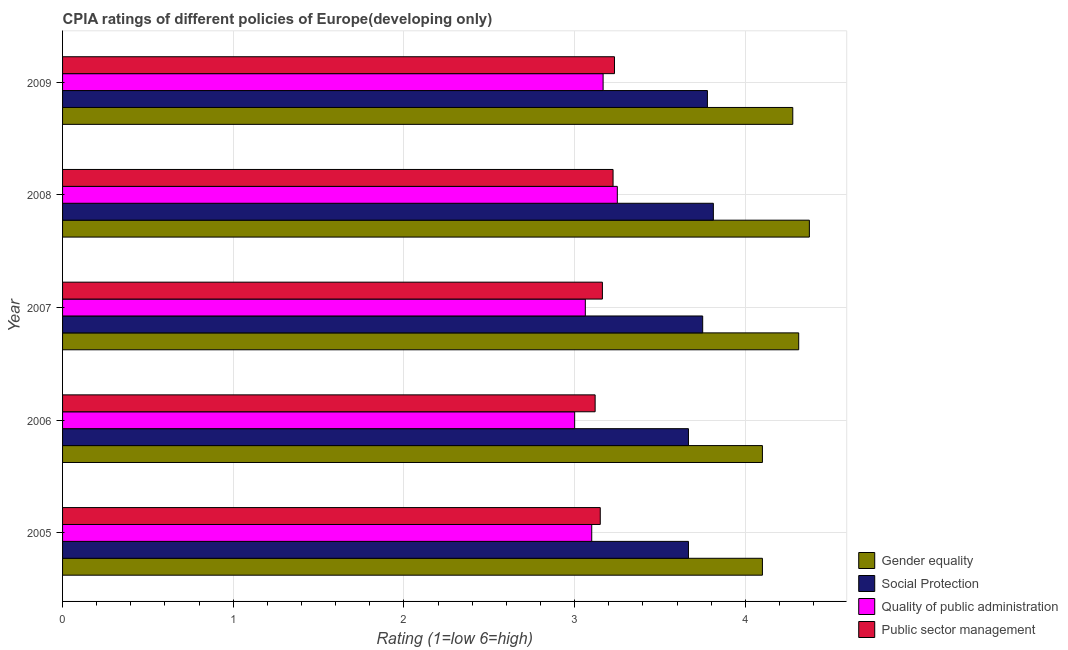How many groups of bars are there?
Your answer should be very brief. 5. Are the number of bars on each tick of the Y-axis equal?
Ensure brevity in your answer.  Yes. How many bars are there on the 2nd tick from the top?
Provide a succinct answer. 4. What is the label of the 4th group of bars from the top?
Offer a terse response. 2006. In how many cases, is the number of bars for a given year not equal to the number of legend labels?
Keep it short and to the point. 0. What is the cpia rating of social protection in 2005?
Your response must be concise. 3.67. Across all years, what is the maximum cpia rating of public sector management?
Offer a very short reply. 3.23. In which year was the cpia rating of gender equality maximum?
Provide a short and direct response. 2008. In which year was the cpia rating of quality of public administration minimum?
Keep it short and to the point. 2006. What is the total cpia rating of public sector management in the graph?
Make the answer very short. 15.89. What is the difference between the cpia rating of public sector management in 2006 and that in 2008?
Provide a succinct answer. -0.1. What is the difference between the cpia rating of social protection in 2006 and the cpia rating of quality of public administration in 2008?
Keep it short and to the point. 0.42. What is the average cpia rating of public sector management per year?
Give a very brief answer. 3.18. In the year 2009, what is the difference between the cpia rating of gender equality and cpia rating of public sector management?
Ensure brevity in your answer.  1.04. In how many years, is the cpia rating of public sector management greater than 0.4 ?
Provide a short and direct response. 5. What is the ratio of the cpia rating of quality of public administration in 2007 to that in 2008?
Provide a succinct answer. 0.94. Is the difference between the cpia rating of social protection in 2005 and 2008 greater than the difference between the cpia rating of gender equality in 2005 and 2008?
Make the answer very short. Yes. What is the difference between the highest and the second highest cpia rating of social protection?
Your answer should be very brief. 0.04. What is the difference between the highest and the lowest cpia rating of gender equality?
Offer a terse response. 0.28. In how many years, is the cpia rating of public sector management greater than the average cpia rating of public sector management taken over all years?
Offer a very short reply. 2. Is the sum of the cpia rating of quality of public administration in 2005 and 2009 greater than the maximum cpia rating of public sector management across all years?
Your answer should be compact. Yes. What does the 4th bar from the top in 2009 represents?
Give a very brief answer. Gender equality. What does the 1st bar from the bottom in 2005 represents?
Your response must be concise. Gender equality. Is it the case that in every year, the sum of the cpia rating of gender equality and cpia rating of social protection is greater than the cpia rating of quality of public administration?
Make the answer very short. Yes. How many bars are there?
Offer a terse response. 20. Are all the bars in the graph horizontal?
Offer a very short reply. Yes. How many years are there in the graph?
Your response must be concise. 5. Are the values on the major ticks of X-axis written in scientific E-notation?
Make the answer very short. No. How are the legend labels stacked?
Your answer should be very brief. Vertical. What is the title of the graph?
Make the answer very short. CPIA ratings of different policies of Europe(developing only). Does "Coal" appear as one of the legend labels in the graph?
Keep it short and to the point. No. What is the label or title of the X-axis?
Provide a succinct answer. Rating (1=low 6=high). What is the Rating (1=low 6=high) of Gender equality in 2005?
Offer a very short reply. 4.1. What is the Rating (1=low 6=high) in Social Protection in 2005?
Your answer should be very brief. 3.67. What is the Rating (1=low 6=high) of Public sector management in 2005?
Keep it short and to the point. 3.15. What is the Rating (1=low 6=high) of Social Protection in 2006?
Provide a succinct answer. 3.67. What is the Rating (1=low 6=high) of Public sector management in 2006?
Provide a short and direct response. 3.12. What is the Rating (1=low 6=high) of Gender equality in 2007?
Offer a terse response. 4.31. What is the Rating (1=low 6=high) in Social Protection in 2007?
Make the answer very short. 3.75. What is the Rating (1=low 6=high) of Quality of public administration in 2007?
Your answer should be very brief. 3.06. What is the Rating (1=low 6=high) of Public sector management in 2007?
Offer a very short reply. 3.16. What is the Rating (1=low 6=high) of Gender equality in 2008?
Offer a very short reply. 4.38. What is the Rating (1=low 6=high) in Social Protection in 2008?
Provide a short and direct response. 3.81. What is the Rating (1=low 6=high) in Public sector management in 2008?
Give a very brief answer. 3.23. What is the Rating (1=low 6=high) of Gender equality in 2009?
Provide a short and direct response. 4.28. What is the Rating (1=low 6=high) of Social Protection in 2009?
Offer a terse response. 3.78. What is the Rating (1=low 6=high) of Quality of public administration in 2009?
Ensure brevity in your answer.  3.17. What is the Rating (1=low 6=high) in Public sector management in 2009?
Offer a terse response. 3.23. Across all years, what is the maximum Rating (1=low 6=high) in Gender equality?
Give a very brief answer. 4.38. Across all years, what is the maximum Rating (1=low 6=high) in Social Protection?
Make the answer very short. 3.81. Across all years, what is the maximum Rating (1=low 6=high) of Quality of public administration?
Your answer should be compact. 3.25. Across all years, what is the maximum Rating (1=low 6=high) of Public sector management?
Your answer should be very brief. 3.23. Across all years, what is the minimum Rating (1=low 6=high) in Gender equality?
Offer a very short reply. 4.1. Across all years, what is the minimum Rating (1=low 6=high) of Social Protection?
Ensure brevity in your answer.  3.67. Across all years, what is the minimum Rating (1=low 6=high) of Public sector management?
Provide a short and direct response. 3.12. What is the total Rating (1=low 6=high) in Gender equality in the graph?
Make the answer very short. 21.17. What is the total Rating (1=low 6=high) in Social Protection in the graph?
Your answer should be compact. 18.67. What is the total Rating (1=low 6=high) in Quality of public administration in the graph?
Ensure brevity in your answer.  15.58. What is the total Rating (1=low 6=high) of Public sector management in the graph?
Ensure brevity in your answer.  15.89. What is the difference between the Rating (1=low 6=high) of Social Protection in 2005 and that in 2006?
Ensure brevity in your answer.  0. What is the difference between the Rating (1=low 6=high) in Quality of public administration in 2005 and that in 2006?
Your answer should be very brief. 0.1. What is the difference between the Rating (1=low 6=high) of Public sector management in 2005 and that in 2006?
Your response must be concise. 0.03. What is the difference between the Rating (1=low 6=high) in Gender equality in 2005 and that in 2007?
Make the answer very short. -0.21. What is the difference between the Rating (1=low 6=high) in Social Protection in 2005 and that in 2007?
Offer a very short reply. -0.08. What is the difference between the Rating (1=low 6=high) in Quality of public administration in 2005 and that in 2007?
Your response must be concise. 0.04. What is the difference between the Rating (1=low 6=high) in Public sector management in 2005 and that in 2007?
Your answer should be compact. -0.01. What is the difference between the Rating (1=low 6=high) in Gender equality in 2005 and that in 2008?
Offer a terse response. -0.28. What is the difference between the Rating (1=low 6=high) of Social Protection in 2005 and that in 2008?
Provide a succinct answer. -0.15. What is the difference between the Rating (1=low 6=high) in Public sector management in 2005 and that in 2008?
Offer a very short reply. -0.07. What is the difference between the Rating (1=low 6=high) of Gender equality in 2005 and that in 2009?
Offer a terse response. -0.18. What is the difference between the Rating (1=low 6=high) of Social Protection in 2005 and that in 2009?
Offer a very short reply. -0.11. What is the difference between the Rating (1=low 6=high) of Quality of public administration in 2005 and that in 2009?
Ensure brevity in your answer.  -0.07. What is the difference between the Rating (1=low 6=high) in Public sector management in 2005 and that in 2009?
Your response must be concise. -0.08. What is the difference between the Rating (1=low 6=high) in Gender equality in 2006 and that in 2007?
Your response must be concise. -0.21. What is the difference between the Rating (1=low 6=high) of Social Protection in 2006 and that in 2007?
Provide a short and direct response. -0.08. What is the difference between the Rating (1=low 6=high) of Quality of public administration in 2006 and that in 2007?
Make the answer very short. -0.06. What is the difference between the Rating (1=low 6=high) in Public sector management in 2006 and that in 2007?
Provide a succinct answer. -0.04. What is the difference between the Rating (1=low 6=high) of Gender equality in 2006 and that in 2008?
Your response must be concise. -0.28. What is the difference between the Rating (1=low 6=high) of Social Protection in 2006 and that in 2008?
Make the answer very short. -0.15. What is the difference between the Rating (1=low 6=high) of Quality of public administration in 2006 and that in 2008?
Your response must be concise. -0.25. What is the difference between the Rating (1=low 6=high) of Public sector management in 2006 and that in 2008?
Ensure brevity in your answer.  -0.1. What is the difference between the Rating (1=low 6=high) of Gender equality in 2006 and that in 2009?
Provide a short and direct response. -0.18. What is the difference between the Rating (1=low 6=high) of Social Protection in 2006 and that in 2009?
Provide a succinct answer. -0.11. What is the difference between the Rating (1=low 6=high) in Quality of public administration in 2006 and that in 2009?
Keep it short and to the point. -0.17. What is the difference between the Rating (1=low 6=high) of Public sector management in 2006 and that in 2009?
Ensure brevity in your answer.  -0.11. What is the difference between the Rating (1=low 6=high) of Gender equality in 2007 and that in 2008?
Offer a very short reply. -0.06. What is the difference between the Rating (1=low 6=high) in Social Protection in 2007 and that in 2008?
Offer a very short reply. -0.06. What is the difference between the Rating (1=low 6=high) of Quality of public administration in 2007 and that in 2008?
Offer a very short reply. -0.19. What is the difference between the Rating (1=low 6=high) of Public sector management in 2007 and that in 2008?
Keep it short and to the point. -0.06. What is the difference between the Rating (1=low 6=high) of Gender equality in 2007 and that in 2009?
Your answer should be very brief. 0.03. What is the difference between the Rating (1=low 6=high) in Social Protection in 2007 and that in 2009?
Ensure brevity in your answer.  -0.03. What is the difference between the Rating (1=low 6=high) in Quality of public administration in 2007 and that in 2009?
Provide a succinct answer. -0.1. What is the difference between the Rating (1=low 6=high) in Public sector management in 2007 and that in 2009?
Offer a terse response. -0.07. What is the difference between the Rating (1=low 6=high) in Gender equality in 2008 and that in 2009?
Ensure brevity in your answer.  0.1. What is the difference between the Rating (1=low 6=high) in Social Protection in 2008 and that in 2009?
Make the answer very short. 0.03. What is the difference between the Rating (1=low 6=high) of Quality of public administration in 2008 and that in 2009?
Your answer should be very brief. 0.08. What is the difference between the Rating (1=low 6=high) in Public sector management in 2008 and that in 2009?
Your response must be concise. -0.01. What is the difference between the Rating (1=low 6=high) of Gender equality in 2005 and the Rating (1=low 6=high) of Social Protection in 2006?
Ensure brevity in your answer.  0.43. What is the difference between the Rating (1=low 6=high) of Gender equality in 2005 and the Rating (1=low 6=high) of Quality of public administration in 2006?
Offer a terse response. 1.1. What is the difference between the Rating (1=low 6=high) of Social Protection in 2005 and the Rating (1=low 6=high) of Public sector management in 2006?
Your answer should be very brief. 0.55. What is the difference between the Rating (1=low 6=high) of Quality of public administration in 2005 and the Rating (1=low 6=high) of Public sector management in 2006?
Make the answer very short. -0.02. What is the difference between the Rating (1=low 6=high) of Gender equality in 2005 and the Rating (1=low 6=high) of Social Protection in 2007?
Keep it short and to the point. 0.35. What is the difference between the Rating (1=low 6=high) in Gender equality in 2005 and the Rating (1=low 6=high) in Quality of public administration in 2007?
Provide a short and direct response. 1.04. What is the difference between the Rating (1=low 6=high) of Gender equality in 2005 and the Rating (1=low 6=high) of Public sector management in 2007?
Make the answer very short. 0.94. What is the difference between the Rating (1=low 6=high) in Social Protection in 2005 and the Rating (1=low 6=high) in Quality of public administration in 2007?
Give a very brief answer. 0.6. What is the difference between the Rating (1=low 6=high) of Social Protection in 2005 and the Rating (1=low 6=high) of Public sector management in 2007?
Keep it short and to the point. 0.5. What is the difference between the Rating (1=low 6=high) in Quality of public administration in 2005 and the Rating (1=low 6=high) in Public sector management in 2007?
Provide a short and direct response. -0.06. What is the difference between the Rating (1=low 6=high) in Gender equality in 2005 and the Rating (1=low 6=high) in Social Protection in 2008?
Your answer should be very brief. 0.29. What is the difference between the Rating (1=low 6=high) of Gender equality in 2005 and the Rating (1=low 6=high) of Quality of public administration in 2008?
Make the answer very short. 0.85. What is the difference between the Rating (1=low 6=high) of Gender equality in 2005 and the Rating (1=low 6=high) of Public sector management in 2008?
Your answer should be compact. 0.88. What is the difference between the Rating (1=low 6=high) in Social Protection in 2005 and the Rating (1=low 6=high) in Quality of public administration in 2008?
Your answer should be compact. 0.42. What is the difference between the Rating (1=low 6=high) in Social Protection in 2005 and the Rating (1=low 6=high) in Public sector management in 2008?
Your answer should be very brief. 0.44. What is the difference between the Rating (1=low 6=high) of Quality of public administration in 2005 and the Rating (1=low 6=high) of Public sector management in 2008?
Your answer should be very brief. -0.12. What is the difference between the Rating (1=low 6=high) in Gender equality in 2005 and the Rating (1=low 6=high) in Social Protection in 2009?
Your response must be concise. 0.32. What is the difference between the Rating (1=low 6=high) of Gender equality in 2005 and the Rating (1=low 6=high) of Public sector management in 2009?
Your answer should be compact. 0.87. What is the difference between the Rating (1=low 6=high) in Social Protection in 2005 and the Rating (1=low 6=high) in Quality of public administration in 2009?
Offer a very short reply. 0.5. What is the difference between the Rating (1=low 6=high) in Social Protection in 2005 and the Rating (1=low 6=high) in Public sector management in 2009?
Your response must be concise. 0.43. What is the difference between the Rating (1=low 6=high) in Quality of public administration in 2005 and the Rating (1=low 6=high) in Public sector management in 2009?
Provide a short and direct response. -0.13. What is the difference between the Rating (1=low 6=high) of Gender equality in 2006 and the Rating (1=low 6=high) of Social Protection in 2007?
Make the answer very short. 0.35. What is the difference between the Rating (1=low 6=high) in Gender equality in 2006 and the Rating (1=low 6=high) in Quality of public administration in 2007?
Offer a very short reply. 1.04. What is the difference between the Rating (1=low 6=high) in Social Protection in 2006 and the Rating (1=low 6=high) in Quality of public administration in 2007?
Provide a succinct answer. 0.6. What is the difference between the Rating (1=low 6=high) of Social Protection in 2006 and the Rating (1=low 6=high) of Public sector management in 2007?
Keep it short and to the point. 0.5. What is the difference between the Rating (1=low 6=high) of Quality of public administration in 2006 and the Rating (1=low 6=high) of Public sector management in 2007?
Offer a very short reply. -0.16. What is the difference between the Rating (1=low 6=high) in Gender equality in 2006 and the Rating (1=low 6=high) in Social Protection in 2008?
Your response must be concise. 0.29. What is the difference between the Rating (1=low 6=high) in Social Protection in 2006 and the Rating (1=low 6=high) in Quality of public administration in 2008?
Your response must be concise. 0.42. What is the difference between the Rating (1=low 6=high) in Social Protection in 2006 and the Rating (1=low 6=high) in Public sector management in 2008?
Offer a terse response. 0.44. What is the difference between the Rating (1=low 6=high) of Quality of public administration in 2006 and the Rating (1=low 6=high) of Public sector management in 2008?
Give a very brief answer. -0.23. What is the difference between the Rating (1=low 6=high) of Gender equality in 2006 and the Rating (1=low 6=high) of Social Protection in 2009?
Your answer should be very brief. 0.32. What is the difference between the Rating (1=low 6=high) in Gender equality in 2006 and the Rating (1=low 6=high) in Public sector management in 2009?
Your response must be concise. 0.87. What is the difference between the Rating (1=low 6=high) in Social Protection in 2006 and the Rating (1=low 6=high) in Public sector management in 2009?
Your response must be concise. 0.43. What is the difference between the Rating (1=low 6=high) of Quality of public administration in 2006 and the Rating (1=low 6=high) of Public sector management in 2009?
Your response must be concise. -0.23. What is the difference between the Rating (1=low 6=high) of Gender equality in 2007 and the Rating (1=low 6=high) of Quality of public administration in 2008?
Ensure brevity in your answer.  1.06. What is the difference between the Rating (1=low 6=high) of Gender equality in 2007 and the Rating (1=low 6=high) of Public sector management in 2008?
Offer a terse response. 1.09. What is the difference between the Rating (1=low 6=high) in Social Protection in 2007 and the Rating (1=low 6=high) in Quality of public administration in 2008?
Ensure brevity in your answer.  0.5. What is the difference between the Rating (1=low 6=high) of Social Protection in 2007 and the Rating (1=low 6=high) of Public sector management in 2008?
Ensure brevity in your answer.  0.53. What is the difference between the Rating (1=low 6=high) in Quality of public administration in 2007 and the Rating (1=low 6=high) in Public sector management in 2008?
Provide a succinct answer. -0.16. What is the difference between the Rating (1=low 6=high) of Gender equality in 2007 and the Rating (1=low 6=high) of Social Protection in 2009?
Keep it short and to the point. 0.53. What is the difference between the Rating (1=low 6=high) of Gender equality in 2007 and the Rating (1=low 6=high) of Quality of public administration in 2009?
Your response must be concise. 1.15. What is the difference between the Rating (1=low 6=high) in Gender equality in 2007 and the Rating (1=low 6=high) in Public sector management in 2009?
Offer a terse response. 1.08. What is the difference between the Rating (1=low 6=high) in Social Protection in 2007 and the Rating (1=low 6=high) in Quality of public administration in 2009?
Offer a very short reply. 0.58. What is the difference between the Rating (1=low 6=high) in Social Protection in 2007 and the Rating (1=low 6=high) in Public sector management in 2009?
Your answer should be compact. 0.52. What is the difference between the Rating (1=low 6=high) of Quality of public administration in 2007 and the Rating (1=low 6=high) of Public sector management in 2009?
Your response must be concise. -0.17. What is the difference between the Rating (1=low 6=high) of Gender equality in 2008 and the Rating (1=low 6=high) of Social Protection in 2009?
Give a very brief answer. 0.6. What is the difference between the Rating (1=low 6=high) in Gender equality in 2008 and the Rating (1=low 6=high) in Quality of public administration in 2009?
Your response must be concise. 1.21. What is the difference between the Rating (1=low 6=high) of Gender equality in 2008 and the Rating (1=low 6=high) of Public sector management in 2009?
Your response must be concise. 1.14. What is the difference between the Rating (1=low 6=high) in Social Protection in 2008 and the Rating (1=low 6=high) in Quality of public administration in 2009?
Provide a short and direct response. 0.65. What is the difference between the Rating (1=low 6=high) of Social Protection in 2008 and the Rating (1=low 6=high) of Public sector management in 2009?
Offer a terse response. 0.58. What is the difference between the Rating (1=low 6=high) in Quality of public administration in 2008 and the Rating (1=low 6=high) in Public sector management in 2009?
Your answer should be very brief. 0.02. What is the average Rating (1=low 6=high) in Gender equality per year?
Make the answer very short. 4.23. What is the average Rating (1=low 6=high) of Social Protection per year?
Provide a short and direct response. 3.73. What is the average Rating (1=low 6=high) of Quality of public administration per year?
Provide a succinct answer. 3.12. What is the average Rating (1=low 6=high) of Public sector management per year?
Your response must be concise. 3.18. In the year 2005, what is the difference between the Rating (1=low 6=high) of Gender equality and Rating (1=low 6=high) of Social Protection?
Give a very brief answer. 0.43. In the year 2005, what is the difference between the Rating (1=low 6=high) of Gender equality and Rating (1=low 6=high) of Quality of public administration?
Your response must be concise. 1. In the year 2005, what is the difference between the Rating (1=low 6=high) of Gender equality and Rating (1=low 6=high) of Public sector management?
Your answer should be very brief. 0.95. In the year 2005, what is the difference between the Rating (1=low 6=high) in Social Protection and Rating (1=low 6=high) in Quality of public administration?
Offer a terse response. 0.57. In the year 2005, what is the difference between the Rating (1=low 6=high) of Social Protection and Rating (1=low 6=high) of Public sector management?
Ensure brevity in your answer.  0.52. In the year 2006, what is the difference between the Rating (1=low 6=high) in Gender equality and Rating (1=low 6=high) in Social Protection?
Provide a short and direct response. 0.43. In the year 2006, what is the difference between the Rating (1=low 6=high) in Gender equality and Rating (1=low 6=high) in Public sector management?
Keep it short and to the point. 0.98. In the year 2006, what is the difference between the Rating (1=low 6=high) of Social Protection and Rating (1=low 6=high) of Quality of public administration?
Offer a terse response. 0.67. In the year 2006, what is the difference between the Rating (1=low 6=high) of Social Protection and Rating (1=low 6=high) of Public sector management?
Your response must be concise. 0.55. In the year 2006, what is the difference between the Rating (1=low 6=high) in Quality of public administration and Rating (1=low 6=high) in Public sector management?
Offer a terse response. -0.12. In the year 2007, what is the difference between the Rating (1=low 6=high) of Gender equality and Rating (1=low 6=high) of Social Protection?
Provide a short and direct response. 0.56. In the year 2007, what is the difference between the Rating (1=low 6=high) in Gender equality and Rating (1=low 6=high) in Quality of public administration?
Provide a succinct answer. 1.25. In the year 2007, what is the difference between the Rating (1=low 6=high) in Gender equality and Rating (1=low 6=high) in Public sector management?
Make the answer very short. 1.15. In the year 2007, what is the difference between the Rating (1=low 6=high) of Social Protection and Rating (1=low 6=high) of Quality of public administration?
Ensure brevity in your answer.  0.69. In the year 2007, what is the difference between the Rating (1=low 6=high) of Social Protection and Rating (1=low 6=high) of Public sector management?
Ensure brevity in your answer.  0.59. In the year 2007, what is the difference between the Rating (1=low 6=high) in Quality of public administration and Rating (1=low 6=high) in Public sector management?
Your answer should be compact. -0.1. In the year 2008, what is the difference between the Rating (1=low 6=high) in Gender equality and Rating (1=low 6=high) in Social Protection?
Your answer should be very brief. 0.56. In the year 2008, what is the difference between the Rating (1=low 6=high) in Gender equality and Rating (1=low 6=high) in Public sector management?
Make the answer very short. 1.15. In the year 2008, what is the difference between the Rating (1=low 6=high) of Social Protection and Rating (1=low 6=high) of Quality of public administration?
Offer a very short reply. 0.56. In the year 2008, what is the difference between the Rating (1=low 6=high) of Social Protection and Rating (1=low 6=high) of Public sector management?
Provide a succinct answer. 0.59. In the year 2008, what is the difference between the Rating (1=low 6=high) in Quality of public administration and Rating (1=low 6=high) in Public sector management?
Your answer should be very brief. 0.03. In the year 2009, what is the difference between the Rating (1=low 6=high) in Gender equality and Rating (1=low 6=high) in Public sector management?
Offer a very short reply. 1.04. In the year 2009, what is the difference between the Rating (1=low 6=high) of Social Protection and Rating (1=low 6=high) of Quality of public administration?
Provide a short and direct response. 0.61. In the year 2009, what is the difference between the Rating (1=low 6=high) of Social Protection and Rating (1=low 6=high) of Public sector management?
Keep it short and to the point. 0.54. In the year 2009, what is the difference between the Rating (1=low 6=high) of Quality of public administration and Rating (1=low 6=high) of Public sector management?
Keep it short and to the point. -0.07. What is the ratio of the Rating (1=low 6=high) in Gender equality in 2005 to that in 2006?
Provide a short and direct response. 1. What is the ratio of the Rating (1=low 6=high) of Quality of public administration in 2005 to that in 2006?
Ensure brevity in your answer.  1.03. What is the ratio of the Rating (1=low 6=high) in Public sector management in 2005 to that in 2006?
Give a very brief answer. 1.01. What is the ratio of the Rating (1=low 6=high) in Gender equality in 2005 to that in 2007?
Your answer should be compact. 0.95. What is the ratio of the Rating (1=low 6=high) in Social Protection in 2005 to that in 2007?
Your answer should be compact. 0.98. What is the ratio of the Rating (1=low 6=high) in Quality of public administration in 2005 to that in 2007?
Offer a very short reply. 1.01. What is the ratio of the Rating (1=low 6=high) in Public sector management in 2005 to that in 2007?
Give a very brief answer. 1. What is the ratio of the Rating (1=low 6=high) in Gender equality in 2005 to that in 2008?
Keep it short and to the point. 0.94. What is the ratio of the Rating (1=low 6=high) in Social Protection in 2005 to that in 2008?
Ensure brevity in your answer.  0.96. What is the ratio of the Rating (1=low 6=high) of Quality of public administration in 2005 to that in 2008?
Provide a succinct answer. 0.95. What is the ratio of the Rating (1=low 6=high) in Public sector management in 2005 to that in 2008?
Provide a succinct answer. 0.98. What is the ratio of the Rating (1=low 6=high) in Gender equality in 2005 to that in 2009?
Your answer should be very brief. 0.96. What is the ratio of the Rating (1=low 6=high) of Social Protection in 2005 to that in 2009?
Your answer should be compact. 0.97. What is the ratio of the Rating (1=low 6=high) of Quality of public administration in 2005 to that in 2009?
Give a very brief answer. 0.98. What is the ratio of the Rating (1=low 6=high) of Public sector management in 2005 to that in 2009?
Make the answer very short. 0.97. What is the ratio of the Rating (1=low 6=high) of Gender equality in 2006 to that in 2007?
Give a very brief answer. 0.95. What is the ratio of the Rating (1=low 6=high) of Social Protection in 2006 to that in 2007?
Offer a very short reply. 0.98. What is the ratio of the Rating (1=low 6=high) in Quality of public administration in 2006 to that in 2007?
Your answer should be very brief. 0.98. What is the ratio of the Rating (1=low 6=high) of Public sector management in 2006 to that in 2007?
Your answer should be compact. 0.99. What is the ratio of the Rating (1=low 6=high) of Gender equality in 2006 to that in 2008?
Offer a very short reply. 0.94. What is the ratio of the Rating (1=low 6=high) of Social Protection in 2006 to that in 2008?
Your answer should be very brief. 0.96. What is the ratio of the Rating (1=low 6=high) in Quality of public administration in 2006 to that in 2008?
Your answer should be very brief. 0.92. What is the ratio of the Rating (1=low 6=high) of Public sector management in 2006 to that in 2008?
Provide a short and direct response. 0.97. What is the ratio of the Rating (1=low 6=high) in Gender equality in 2006 to that in 2009?
Your answer should be compact. 0.96. What is the ratio of the Rating (1=low 6=high) in Social Protection in 2006 to that in 2009?
Provide a short and direct response. 0.97. What is the ratio of the Rating (1=low 6=high) in Public sector management in 2006 to that in 2009?
Provide a succinct answer. 0.96. What is the ratio of the Rating (1=low 6=high) in Gender equality in 2007 to that in 2008?
Provide a short and direct response. 0.99. What is the ratio of the Rating (1=low 6=high) of Social Protection in 2007 to that in 2008?
Offer a very short reply. 0.98. What is the ratio of the Rating (1=low 6=high) in Quality of public administration in 2007 to that in 2008?
Provide a short and direct response. 0.94. What is the ratio of the Rating (1=low 6=high) of Public sector management in 2007 to that in 2008?
Offer a very short reply. 0.98. What is the ratio of the Rating (1=low 6=high) of Gender equality in 2007 to that in 2009?
Ensure brevity in your answer.  1.01. What is the ratio of the Rating (1=low 6=high) in Quality of public administration in 2007 to that in 2009?
Offer a very short reply. 0.97. What is the ratio of the Rating (1=low 6=high) of Public sector management in 2007 to that in 2009?
Offer a very short reply. 0.98. What is the ratio of the Rating (1=low 6=high) in Gender equality in 2008 to that in 2009?
Your answer should be very brief. 1.02. What is the ratio of the Rating (1=low 6=high) of Social Protection in 2008 to that in 2009?
Keep it short and to the point. 1.01. What is the ratio of the Rating (1=low 6=high) of Quality of public administration in 2008 to that in 2009?
Offer a very short reply. 1.03. What is the difference between the highest and the second highest Rating (1=low 6=high) of Gender equality?
Make the answer very short. 0.06. What is the difference between the highest and the second highest Rating (1=low 6=high) of Social Protection?
Provide a short and direct response. 0.03. What is the difference between the highest and the second highest Rating (1=low 6=high) in Quality of public administration?
Provide a short and direct response. 0.08. What is the difference between the highest and the second highest Rating (1=low 6=high) in Public sector management?
Your answer should be very brief. 0.01. What is the difference between the highest and the lowest Rating (1=low 6=high) of Gender equality?
Offer a very short reply. 0.28. What is the difference between the highest and the lowest Rating (1=low 6=high) in Social Protection?
Ensure brevity in your answer.  0.15. What is the difference between the highest and the lowest Rating (1=low 6=high) in Quality of public administration?
Keep it short and to the point. 0.25. What is the difference between the highest and the lowest Rating (1=low 6=high) in Public sector management?
Offer a terse response. 0.11. 